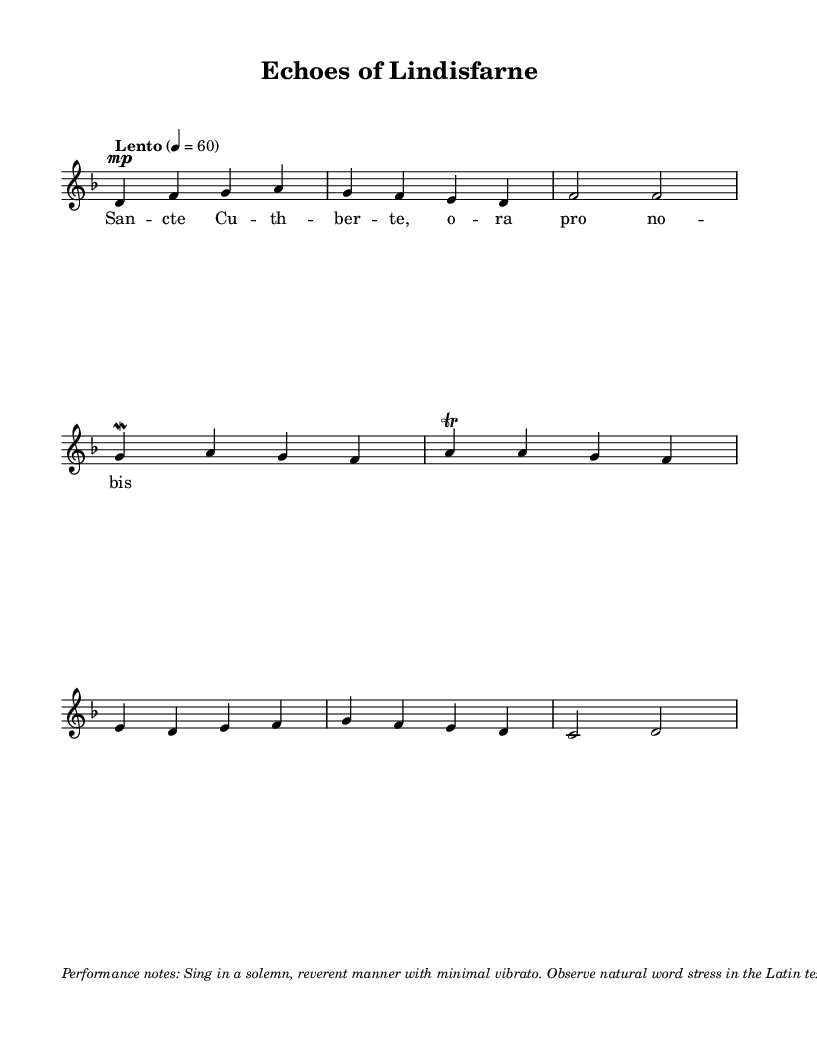What is the key signature of this music? The key signature is D minor, which has one flat (B flat). It can be identified by looking at the key signature indicated at the beginning of the staff.
Answer: D minor What is the time signature? The time signature is 4/4, which is shown at the beginning of the score. It tells us that there are four beats in each measure.
Answer: 4/4 What is the tempo marking for this piece? The tempo marking is "Lento" at a quarter note equals 60 beats per minute. This is indicated near the beginning of the score, guiding the performance speed.
Answer: Lento, 4 = 60 How many measures are present in the score? There are five measures in the score, which can be counted visually by looking at the bar lines that separate the musical phrases.
Answer: Five What type of ornamentation is used in the second measure? The type of ornamentation present is a mordent, which is indicated with the notation in the second measure next to the note g. It signifies a rapid alternation between the main note and the note directly below it.
Answer: Mordent What is the text of the lyrics associated with the melody? The lyrics associated with this melody are "Sancte Cuthberte, ora pro nobis." This can be found beneath the notes, aligning with the melody.
Answer: Sancte Cuthberte, ora pro nobis 